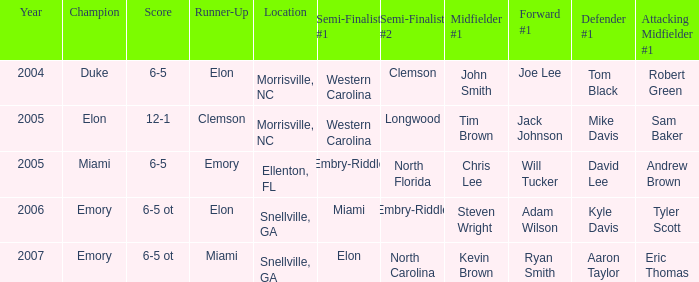When Embry-Riddle made it to the first semi finalist slot, list all the runners up. Emory. 